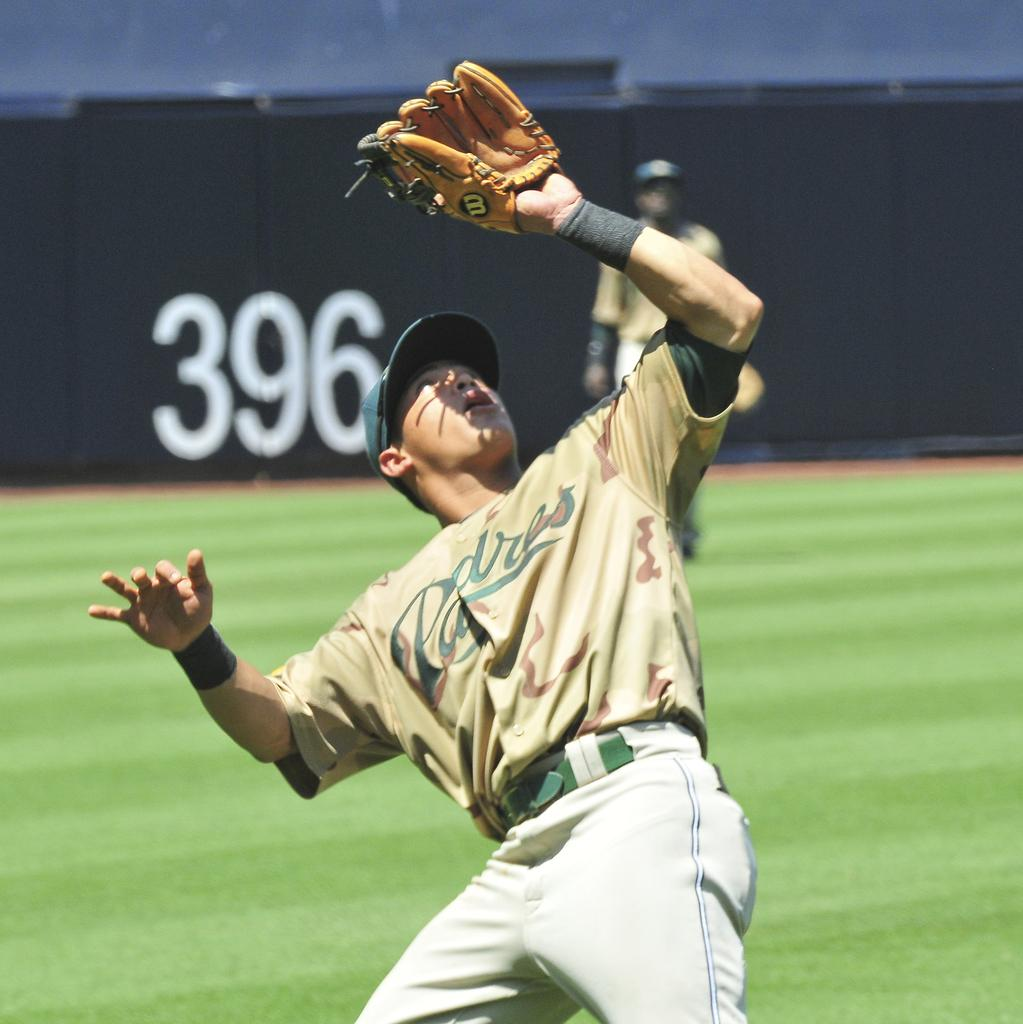<image>
Relay a brief, clear account of the picture shown. a san diego padre baseball player trying to catch the ball 